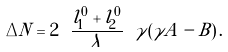Convert formula to latex. <formula><loc_0><loc_0><loc_500><loc_500>\Delta N = 2 \ \frac { l _ { 1 } ^ { 0 } + l _ { 2 } ^ { 0 } } { \lambda } \ \gamma ( \gamma A - B ) \, .</formula> 